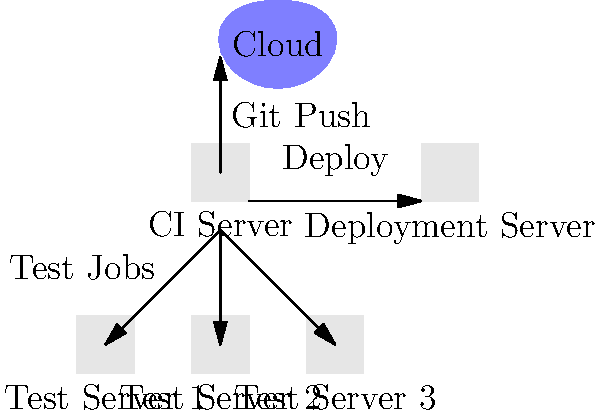Analyze the given network topology diagram for a distributed CI/CD system. What is the minimum number of successful test jobs required before the deployment process can begin? To determine the minimum number of successful test jobs required before deployment, let's analyze the diagram step by step:

1. The diagram shows a cloud environment, likely representing a source code repository (e.g., GitHub, GitLab).

2. There's a CI Server connected to the cloud, which receives code updates (Git Push).

3. The CI Server is connected to three Test Servers (Test Server 1, 2, and 3).

4. There's a Deployment Server connected to the CI Server.

5. The arrows from the CI Server to the Test Servers indicate that test jobs are distributed to these servers.

6. The arrow from the CI Server to the Deployment Server suggests that deployment occurs after the testing phase.

7. Since there are three separate Test Servers, it's likely that the system is designed to run multiple test jobs in parallel for faster processing.

8. In a typical CI/CD pipeline, all tests must pass before deployment can occur.

9. However, the question asks for the "minimum" number of successful test jobs required.

10. Given that there are three Test Servers, and assuming each server runs at least one job, the minimum number of successful test jobs would be 3.

This setup ensures that at least one test job has been successfully executed on each Test Server, providing a basic level of confidence in the code quality across different testing environments or scenarios before proceeding to deployment.
Answer: 3 